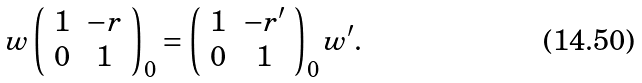Convert formula to latex. <formula><loc_0><loc_0><loc_500><loc_500>w \left ( \begin{array} { c c } 1 & - r \\ 0 & 1 \end{array} \right ) _ { 0 } = \left ( \begin{array} { c c } 1 & - r ^ { \prime } \\ 0 & 1 \end{array} \right ) _ { 0 } w ^ { \prime } .</formula> 